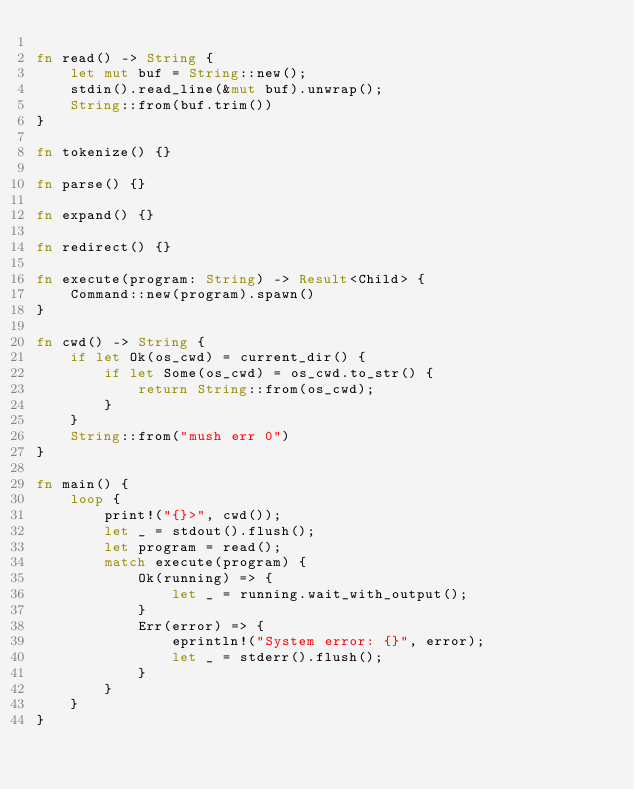Convert code to text. <code><loc_0><loc_0><loc_500><loc_500><_Rust_>
fn read() -> String {
    let mut buf = String::new();
    stdin().read_line(&mut buf).unwrap();
    String::from(buf.trim())
}

fn tokenize() {}

fn parse() {}

fn expand() {}

fn redirect() {}

fn execute(program: String) -> Result<Child> {
    Command::new(program).spawn()
}

fn cwd() -> String {
    if let Ok(os_cwd) = current_dir() {
        if let Some(os_cwd) = os_cwd.to_str() {
            return String::from(os_cwd);
        }
    }
    String::from("mush err 0")
}

fn main() {
    loop {
        print!("{}>", cwd());
        let _ = stdout().flush();
        let program = read();
        match execute(program) {
            Ok(running) => {
                let _ = running.wait_with_output();
            }
            Err(error) => {
                eprintln!("System error: {}", error);
                let _ = stderr().flush();
            }
        }
    }
}
</code> 